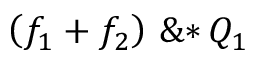Convert formula to latex. <formula><loc_0><loc_0><loc_500><loc_500>\left ( \, { { f } _ { 1 } } + { { f } _ { 2 } } \, \right ) \, \& * \, { { Q } _ { 1 } }</formula> 